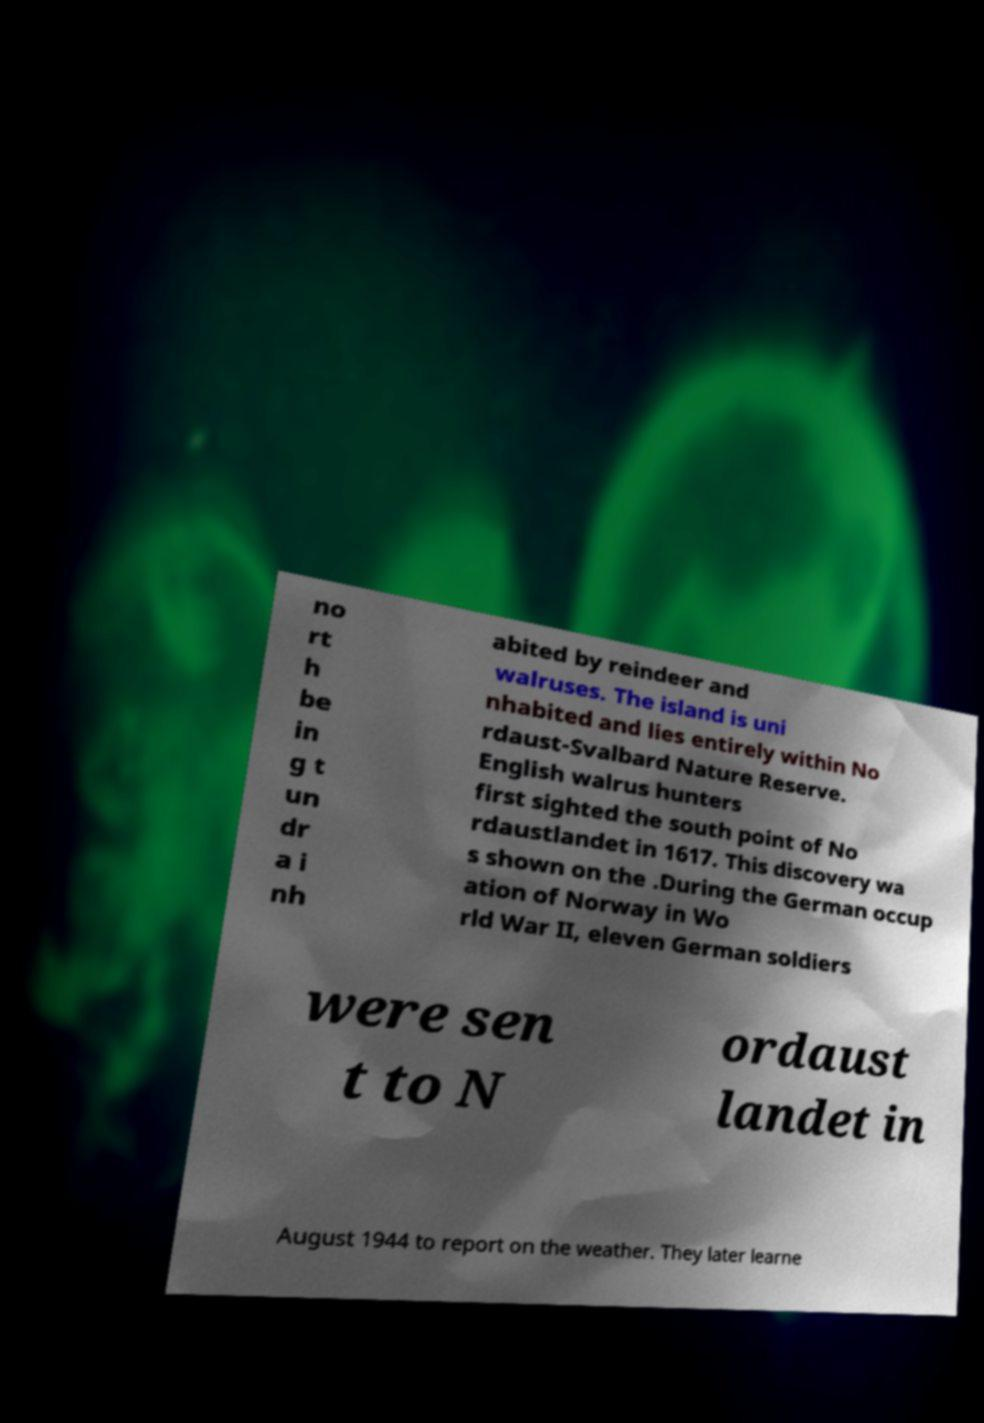Please identify and transcribe the text found in this image. no rt h be in g t un dr a i nh abited by reindeer and walruses. The island is uni nhabited and lies entirely within No rdaust-Svalbard Nature Reserve. English walrus hunters first sighted the south point of No rdaustlandet in 1617. This discovery wa s shown on the .During the German occup ation of Norway in Wo rld War II, eleven German soldiers were sen t to N ordaust landet in August 1944 to report on the weather. They later learne 